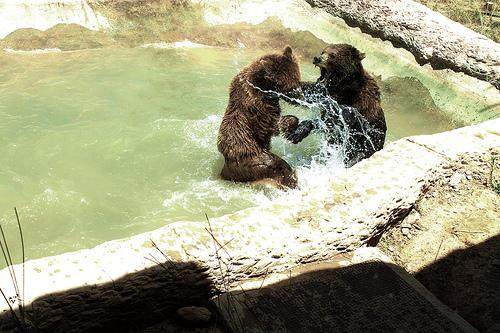Summarize the focal point and actions taking place in the image. The image focuses on two bears fighting in a pool of water, causing water splashes and ripples. Give a brief overview of the primary subject and their action in the image. Two brown bears are standing and fighting in a pool of green, murky water. Provide a concise summary of the major subject and their behaviour in the photograph. The photo depicts two bears engaging in a fight while standing in a green water pool, causing splashes. State the primary entities in the image and describe what they are doing. The image features two bears playfully fighting while standing in a pool of murky water surrounded by nature. What is the main scene in the picture, and what are the major elements involved? The scene shows two bears fighting in water, creating water splashes, surrounded by a stone border and greenery. What are the most important components and their functions in this picture? The key components are two brown bears play-fighting in a water pool, making splashes and surrounded by a stone border. Tell the main theme of the picture, and specify the actions involved in the scene. The image showcases a pair of brown bears play-fighting in water, creating splashes and ripples. State the predominant activity and the main participants in this picture. Two brown bears are engaged in a playful fight in a pool of green water. Describe the central focus of the image and the interaction between the elements. The image features two brown bears standing upright and fighting in a pool of water, while splashing and causing ripples. Mention the chief subject and their conduct in the image. The main subject is two brown bears standing in water, involved in a physical altercation. 